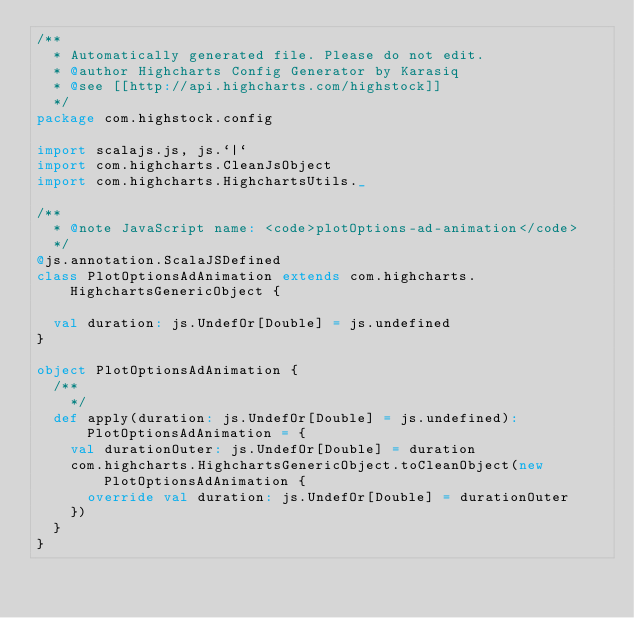Convert code to text. <code><loc_0><loc_0><loc_500><loc_500><_Scala_>/**
  * Automatically generated file. Please do not edit.
  * @author Highcharts Config Generator by Karasiq
  * @see [[http://api.highcharts.com/highstock]]
  */
package com.highstock.config

import scalajs.js, js.`|`
import com.highcharts.CleanJsObject
import com.highcharts.HighchartsUtils._

/**
  * @note JavaScript name: <code>plotOptions-ad-animation</code>
  */
@js.annotation.ScalaJSDefined
class PlotOptionsAdAnimation extends com.highcharts.HighchartsGenericObject {

  val duration: js.UndefOr[Double] = js.undefined
}

object PlotOptionsAdAnimation {
  /**
    */
  def apply(duration: js.UndefOr[Double] = js.undefined): PlotOptionsAdAnimation = {
    val durationOuter: js.UndefOr[Double] = duration
    com.highcharts.HighchartsGenericObject.toCleanObject(new PlotOptionsAdAnimation {
      override val duration: js.UndefOr[Double] = durationOuter
    })
  }
}
</code> 